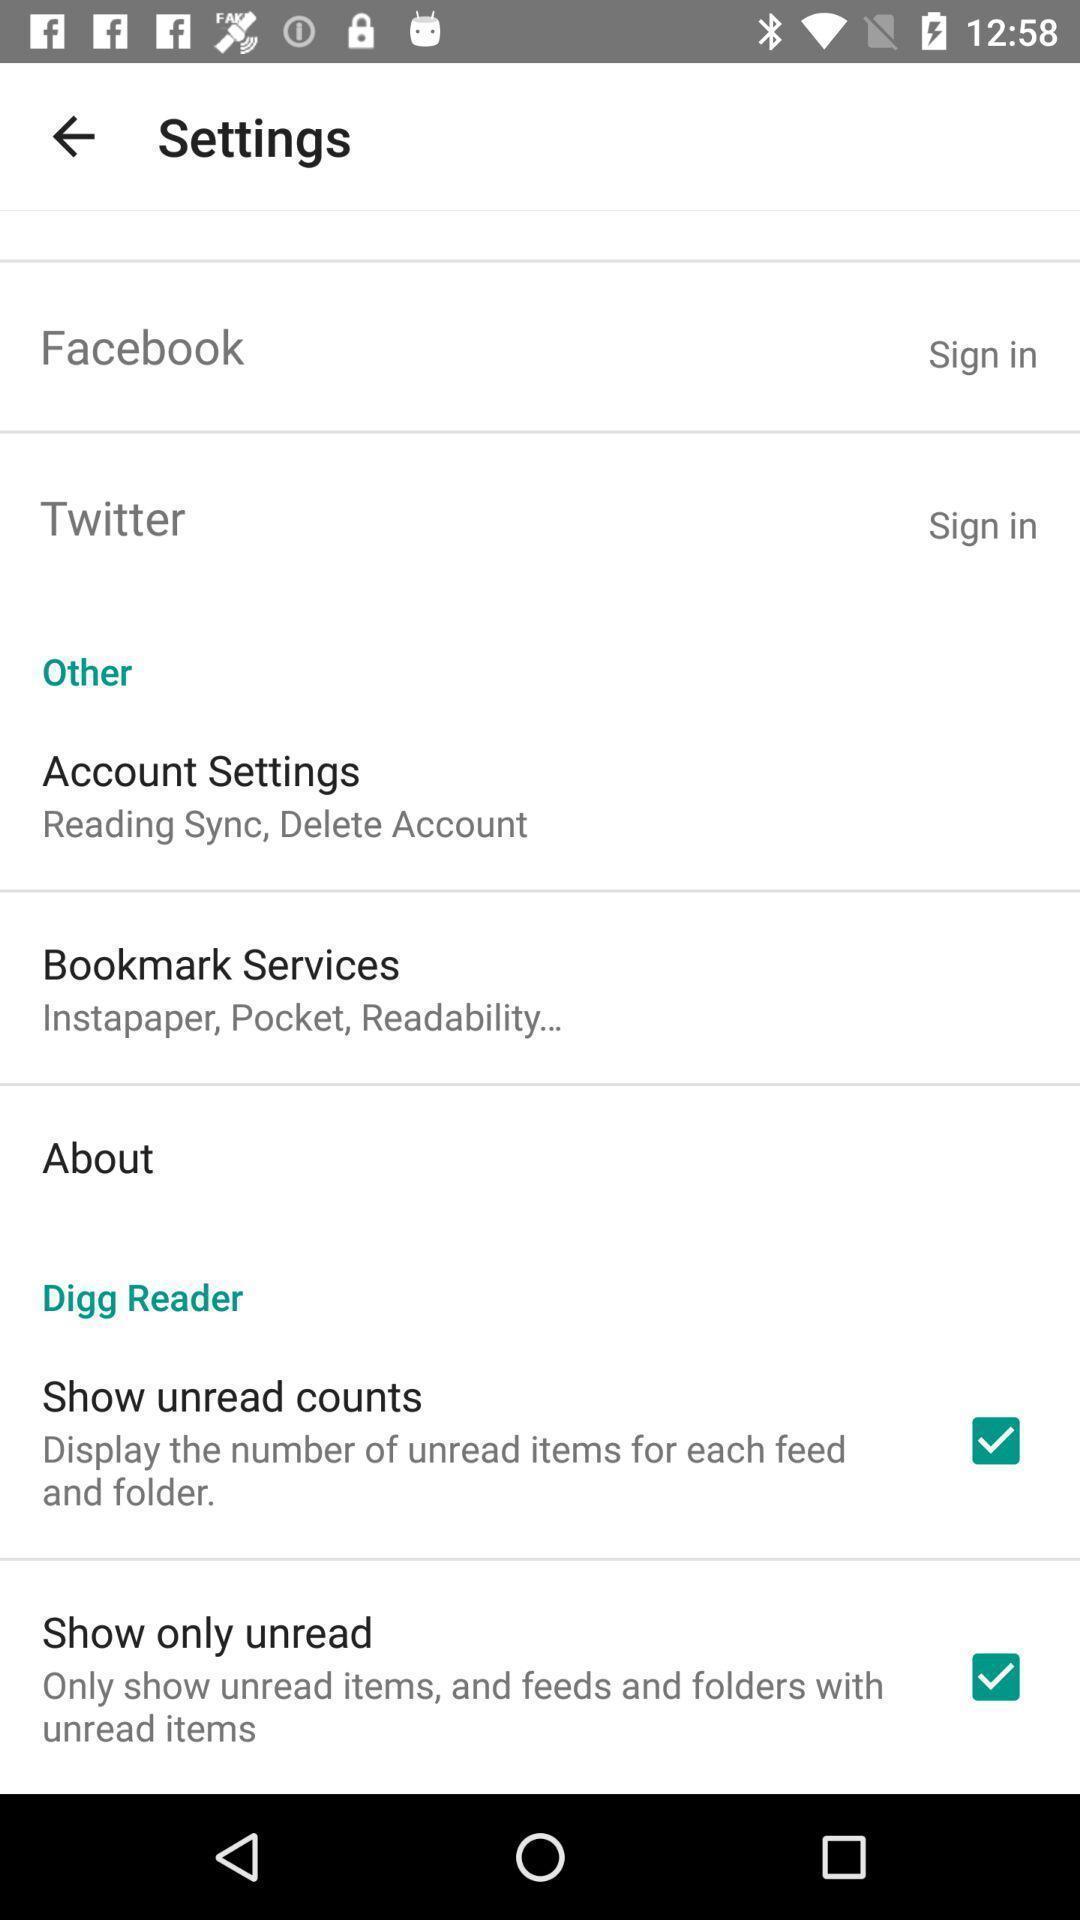Tell me what you see in this picture. Settings page. 